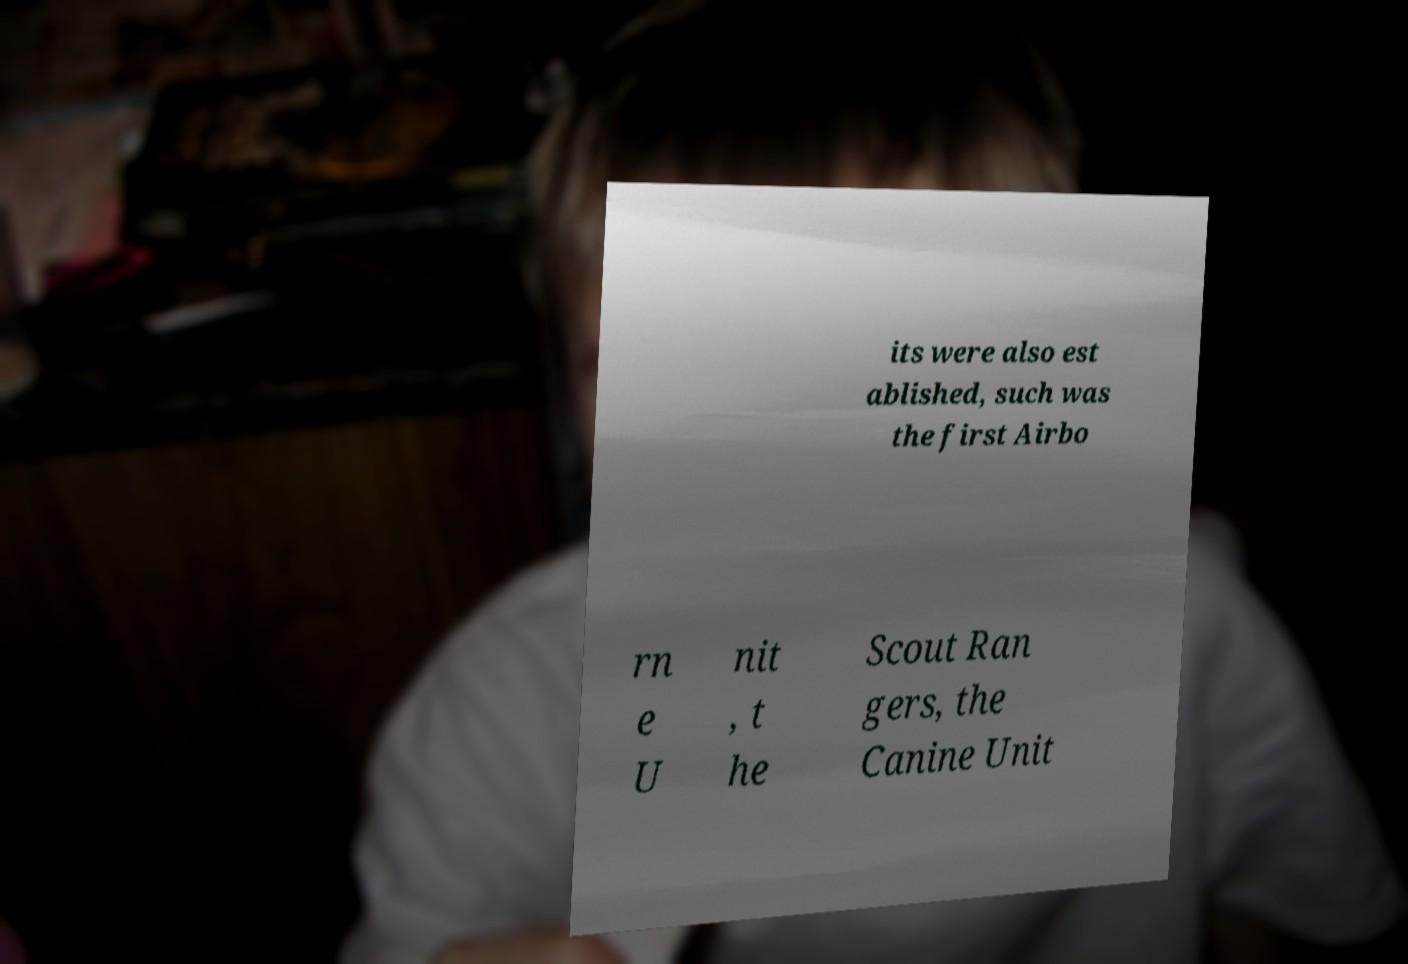Can you read and provide the text displayed in the image?This photo seems to have some interesting text. Can you extract and type it out for me? its were also est ablished, such was the first Airbo rn e U nit , t he Scout Ran gers, the Canine Unit 